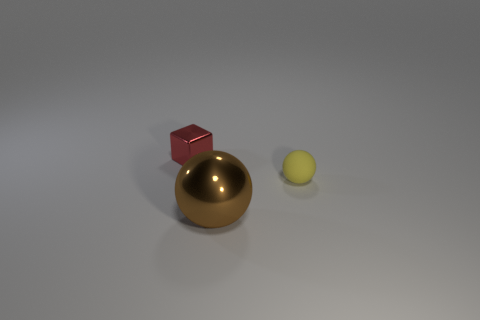Are there any other things that are made of the same material as the yellow thing?
Keep it short and to the point. No. The tiny object to the right of the metal object to the right of the tiny thing that is behind the tiny yellow ball is made of what material?
Offer a very short reply. Rubber. What size is the brown object that is made of the same material as the small red thing?
Provide a short and direct response. Large. There is a yellow sphere; is it the same size as the ball that is in front of the yellow sphere?
Offer a very short reply. No. There is a ball to the left of the small thing that is in front of the tiny metallic thing; what number of red metal cubes are to the left of it?
Offer a very short reply. 1. There is a metal cube; are there any brown metal spheres left of it?
Make the answer very short. No. There is a yellow rubber thing; what shape is it?
Offer a terse response. Sphere. There is a object that is in front of the tiny yellow sphere that is right of the metal thing in front of the small cube; what shape is it?
Your answer should be compact. Sphere. What number of other objects are there of the same shape as the brown object?
Provide a short and direct response. 1. There is a small thing on the right side of the metal thing in front of the red object; what is its material?
Your answer should be compact. Rubber. 